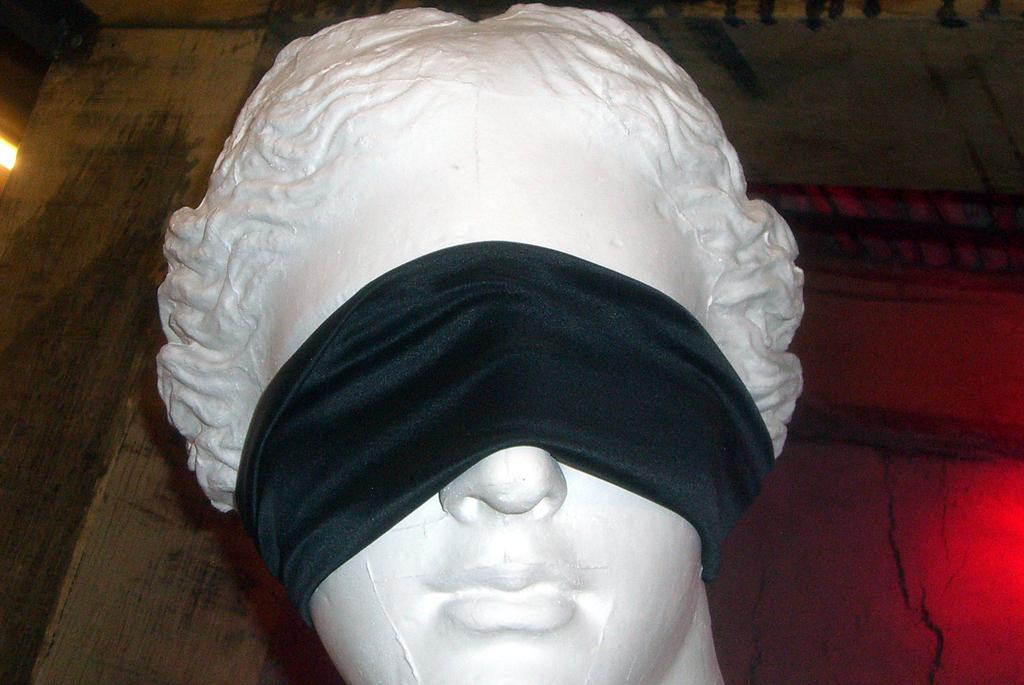What is the main subject of the image? The main subject of the image is a statue. What is a notable feature of the statue? The statue has a blindfold. What type of shoes is the statue wearing in the image? The statue does not have shoes, as it is a statue and not a person. 